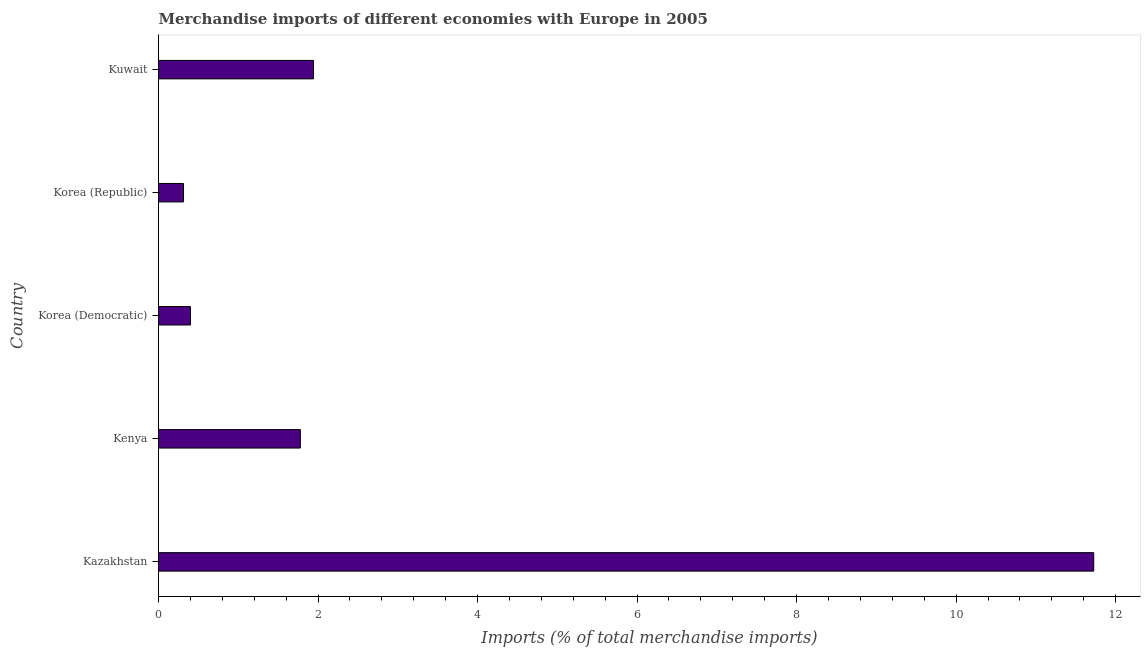Does the graph contain any zero values?
Your response must be concise. No. Does the graph contain grids?
Ensure brevity in your answer.  No. What is the title of the graph?
Your response must be concise. Merchandise imports of different economies with Europe in 2005. What is the label or title of the X-axis?
Your answer should be compact. Imports (% of total merchandise imports). What is the label or title of the Y-axis?
Keep it short and to the point. Country. What is the merchandise imports in Korea (Republic)?
Give a very brief answer. 0.31. Across all countries, what is the maximum merchandise imports?
Your answer should be very brief. 11.73. Across all countries, what is the minimum merchandise imports?
Make the answer very short. 0.31. In which country was the merchandise imports maximum?
Provide a short and direct response. Kazakhstan. What is the sum of the merchandise imports?
Offer a terse response. 16.16. What is the difference between the merchandise imports in Kazakhstan and Korea (Republic)?
Ensure brevity in your answer.  11.41. What is the average merchandise imports per country?
Offer a very short reply. 3.23. What is the median merchandise imports?
Offer a terse response. 1.78. What is the ratio of the merchandise imports in Kenya to that in Kuwait?
Give a very brief answer. 0.92. Is the merchandise imports in Korea (Democratic) less than that in Kuwait?
Offer a very short reply. Yes. Is the difference between the merchandise imports in Kenya and Korea (Democratic) greater than the difference between any two countries?
Your response must be concise. No. What is the difference between the highest and the second highest merchandise imports?
Give a very brief answer. 9.78. Is the sum of the merchandise imports in Kenya and Kuwait greater than the maximum merchandise imports across all countries?
Your answer should be very brief. No. What is the difference between the highest and the lowest merchandise imports?
Provide a short and direct response. 11.41. In how many countries, is the merchandise imports greater than the average merchandise imports taken over all countries?
Your response must be concise. 1. Are all the bars in the graph horizontal?
Provide a short and direct response. Yes. How many countries are there in the graph?
Keep it short and to the point. 5. What is the difference between two consecutive major ticks on the X-axis?
Ensure brevity in your answer.  2. Are the values on the major ticks of X-axis written in scientific E-notation?
Make the answer very short. No. What is the Imports (% of total merchandise imports) in Kazakhstan?
Your response must be concise. 11.73. What is the Imports (% of total merchandise imports) in Kenya?
Offer a very short reply. 1.78. What is the Imports (% of total merchandise imports) of Korea (Democratic)?
Offer a very short reply. 0.4. What is the Imports (% of total merchandise imports) in Korea (Republic)?
Your answer should be compact. 0.31. What is the Imports (% of total merchandise imports) of Kuwait?
Provide a succinct answer. 1.94. What is the difference between the Imports (% of total merchandise imports) in Kazakhstan and Kenya?
Provide a short and direct response. 9.95. What is the difference between the Imports (% of total merchandise imports) in Kazakhstan and Korea (Democratic)?
Make the answer very short. 11.32. What is the difference between the Imports (% of total merchandise imports) in Kazakhstan and Korea (Republic)?
Make the answer very short. 11.41. What is the difference between the Imports (% of total merchandise imports) in Kazakhstan and Kuwait?
Give a very brief answer. 9.78. What is the difference between the Imports (% of total merchandise imports) in Kenya and Korea (Democratic)?
Offer a terse response. 1.38. What is the difference between the Imports (% of total merchandise imports) in Kenya and Korea (Republic)?
Give a very brief answer. 1.46. What is the difference between the Imports (% of total merchandise imports) in Kenya and Kuwait?
Give a very brief answer. -0.17. What is the difference between the Imports (% of total merchandise imports) in Korea (Democratic) and Korea (Republic)?
Offer a very short reply. 0.09. What is the difference between the Imports (% of total merchandise imports) in Korea (Democratic) and Kuwait?
Give a very brief answer. -1.54. What is the difference between the Imports (% of total merchandise imports) in Korea (Republic) and Kuwait?
Keep it short and to the point. -1.63. What is the ratio of the Imports (% of total merchandise imports) in Kazakhstan to that in Kenya?
Offer a terse response. 6.59. What is the ratio of the Imports (% of total merchandise imports) in Kazakhstan to that in Korea (Democratic)?
Keep it short and to the point. 29.28. What is the ratio of the Imports (% of total merchandise imports) in Kazakhstan to that in Korea (Republic)?
Your answer should be compact. 37.41. What is the ratio of the Imports (% of total merchandise imports) in Kazakhstan to that in Kuwait?
Ensure brevity in your answer.  6.03. What is the ratio of the Imports (% of total merchandise imports) in Kenya to that in Korea (Democratic)?
Your answer should be very brief. 4.44. What is the ratio of the Imports (% of total merchandise imports) in Kenya to that in Korea (Republic)?
Your answer should be very brief. 5.67. What is the ratio of the Imports (% of total merchandise imports) in Kenya to that in Kuwait?
Your answer should be very brief. 0.92. What is the ratio of the Imports (% of total merchandise imports) in Korea (Democratic) to that in Korea (Republic)?
Your answer should be very brief. 1.28. What is the ratio of the Imports (% of total merchandise imports) in Korea (Democratic) to that in Kuwait?
Your response must be concise. 0.21. What is the ratio of the Imports (% of total merchandise imports) in Korea (Republic) to that in Kuwait?
Your answer should be compact. 0.16. 